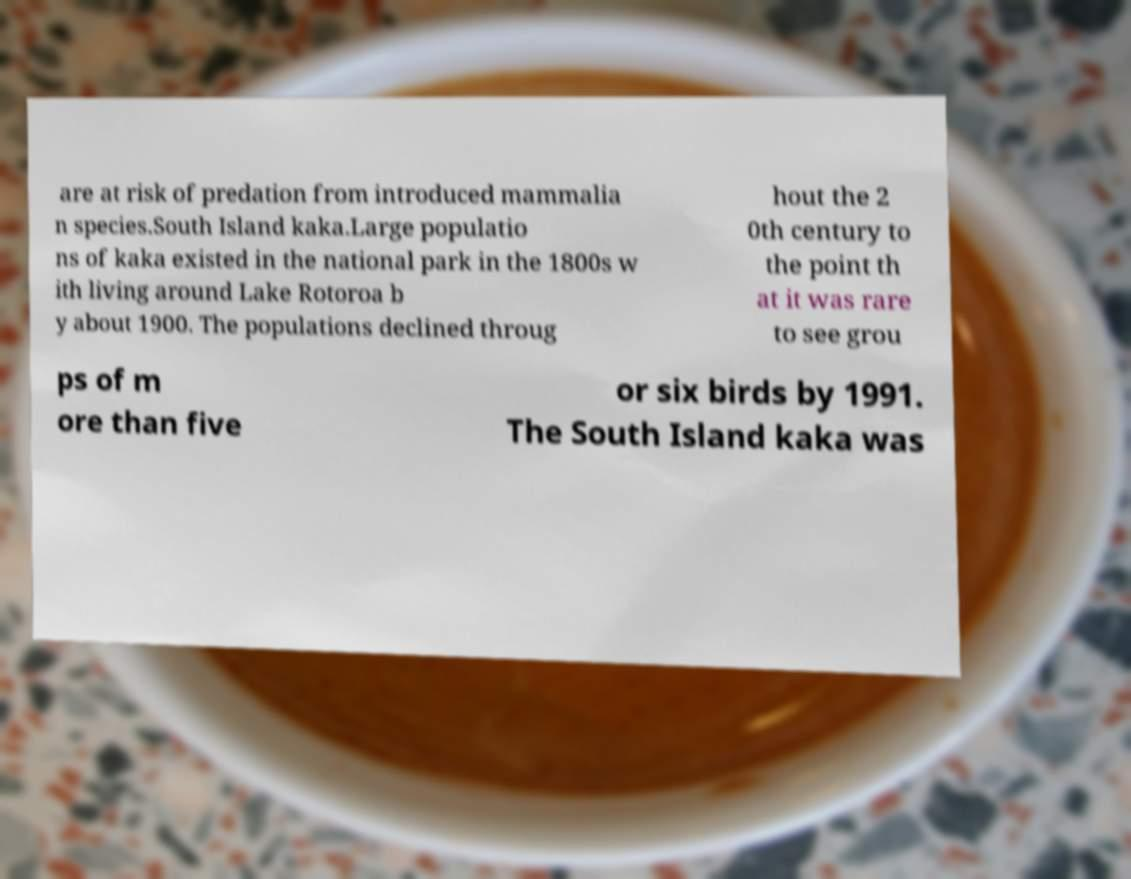What messages or text are displayed in this image? I need them in a readable, typed format. are at risk of predation from introduced mammalia n species.South Island kaka.Large populatio ns of kaka existed in the national park in the 1800s w ith living around Lake Rotoroa b y about 1900. The populations declined throug hout the 2 0th century to the point th at it was rare to see grou ps of m ore than five or six birds by 1991. The South Island kaka was 